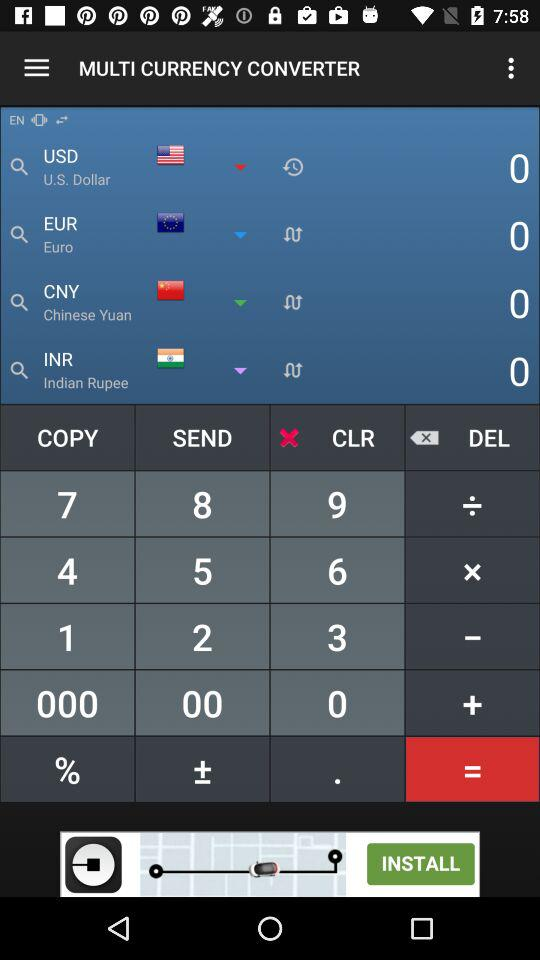What is the short form of the Chinese Yuan? The short form of the Chinese Yuan is CNY. 